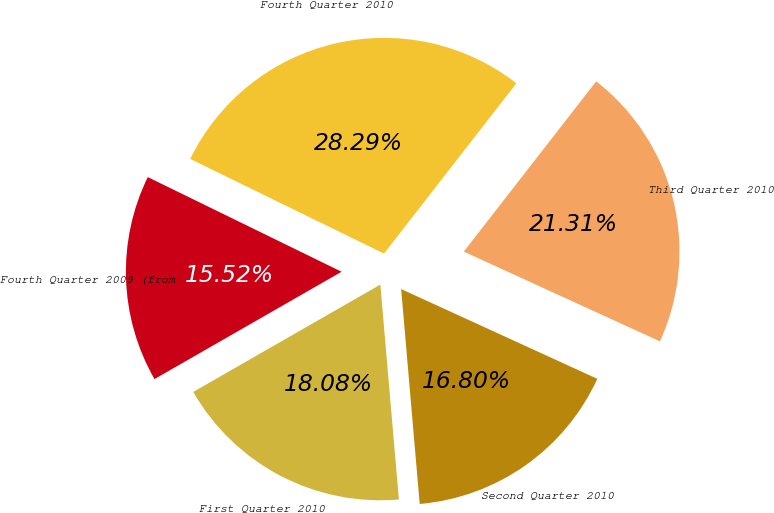Convert chart to OTSL. <chart><loc_0><loc_0><loc_500><loc_500><pie_chart><fcel>Fourth Quarter 2010<fcel>Third Quarter 2010<fcel>Second Quarter 2010<fcel>First Quarter 2010<fcel>Fourth Quarter 2009 (from<nl><fcel>28.29%<fcel>21.31%<fcel>16.8%<fcel>18.08%<fcel>15.52%<nl></chart> 